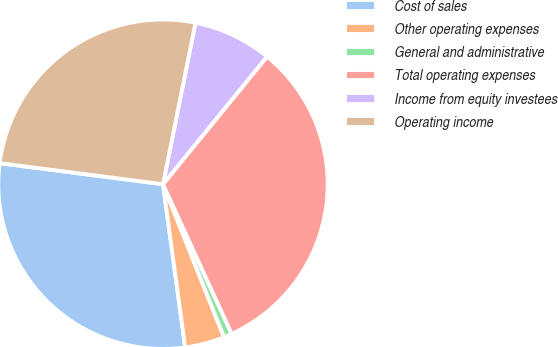<chart> <loc_0><loc_0><loc_500><loc_500><pie_chart><fcel>Cost of sales<fcel>Other operating expenses<fcel>General and administrative<fcel>Total operating expenses<fcel>Income from equity investees<fcel>Operating income<nl><fcel>29.19%<fcel>3.89%<fcel>0.81%<fcel>32.27%<fcel>7.72%<fcel>26.12%<nl></chart> 